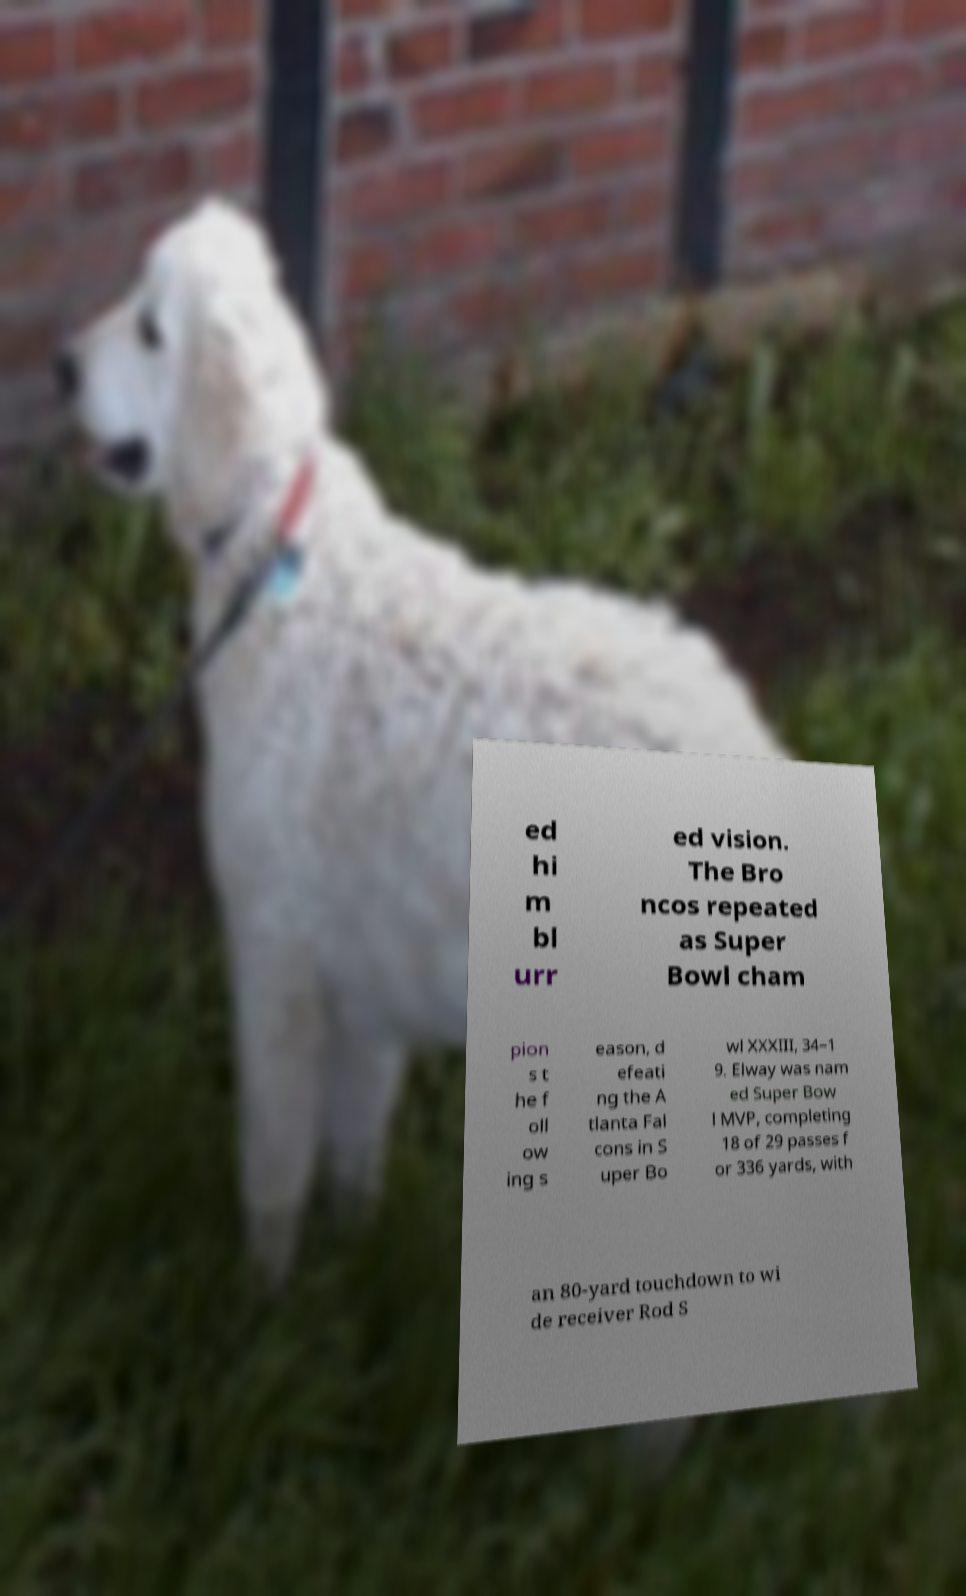Can you read and provide the text displayed in the image?This photo seems to have some interesting text. Can you extract and type it out for me? ed hi m bl urr ed vision. The Bro ncos repeated as Super Bowl cham pion s t he f oll ow ing s eason, d efeati ng the A tlanta Fal cons in S uper Bo wl XXXIII, 34–1 9. Elway was nam ed Super Bow l MVP, completing 18 of 29 passes f or 336 yards, with an 80-yard touchdown to wi de receiver Rod S 